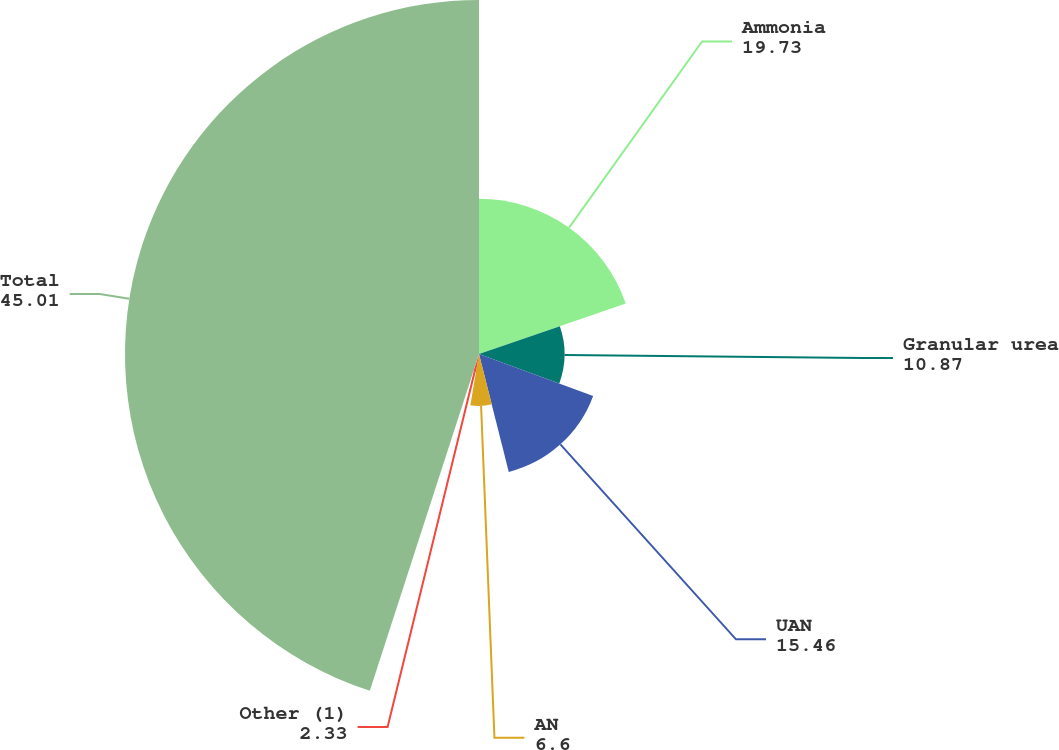Convert chart to OTSL. <chart><loc_0><loc_0><loc_500><loc_500><pie_chart><fcel>Ammonia<fcel>Granular urea<fcel>UAN<fcel>AN<fcel>Other (1)<fcel>Total<nl><fcel>19.73%<fcel>10.87%<fcel>15.46%<fcel>6.6%<fcel>2.33%<fcel>45.01%<nl></chart> 